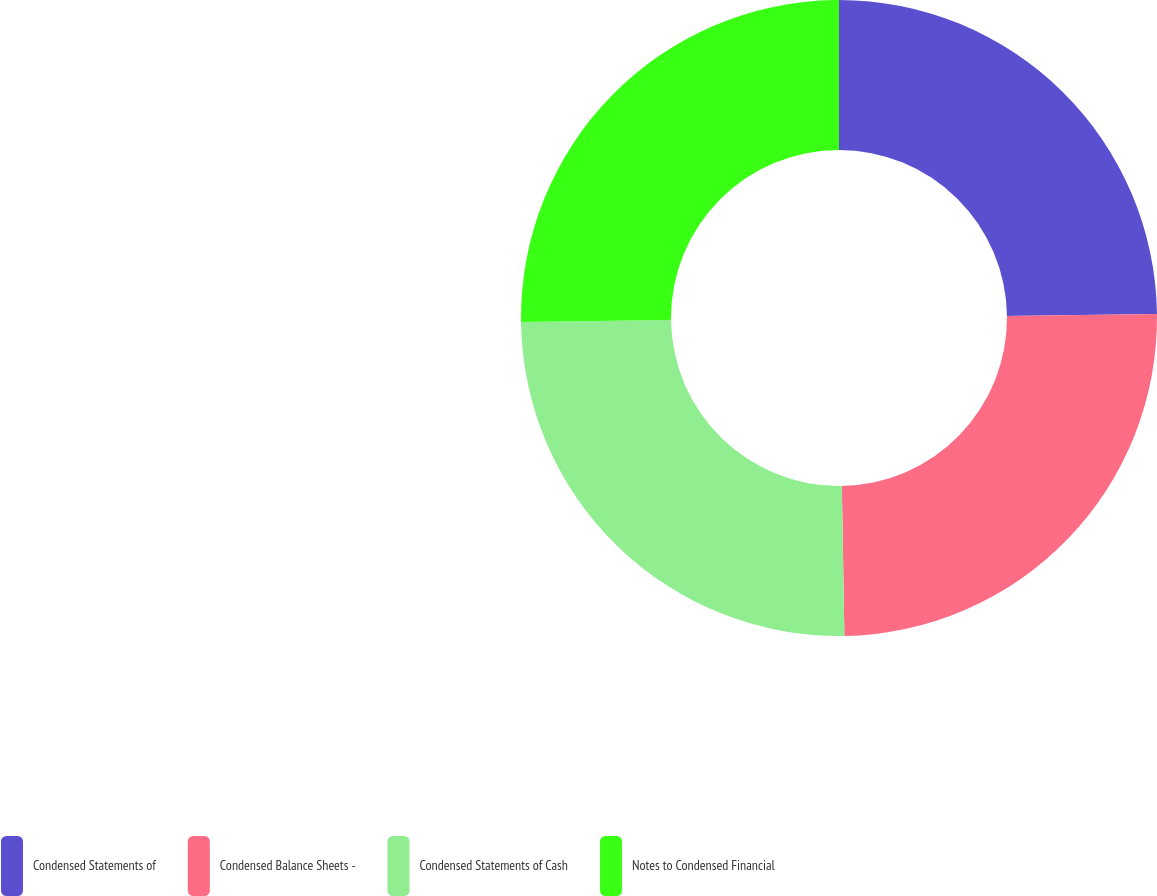<chart> <loc_0><loc_0><loc_500><loc_500><pie_chart><fcel>Condensed Statements of<fcel>Condensed Balance Sheets -<fcel>Condensed Statements of Cash<fcel>Notes to Condensed Financial<nl><fcel>24.8%<fcel>24.93%<fcel>25.07%<fcel>25.2%<nl></chart> 